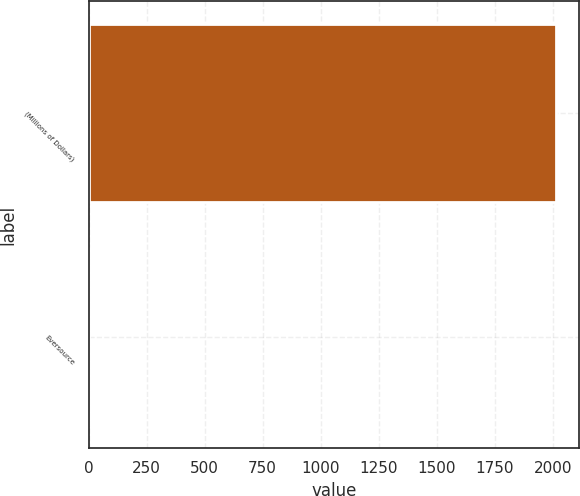<chart> <loc_0><loc_0><loc_500><loc_500><bar_chart><fcel>(Millions of Dollars)<fcel>Eversource<nl><fcel>2014<fcel>0.4<nl></chart> 